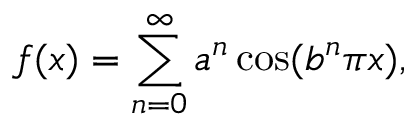Convert formula to latex. <formula><loc_0><loc_0><loc_500><loc_500>f ( x ) = \sum _ { n = 0 } ^ { \infty } a ^ { n } \cos ( b ^ { n } \pi x ) ,</formula> 